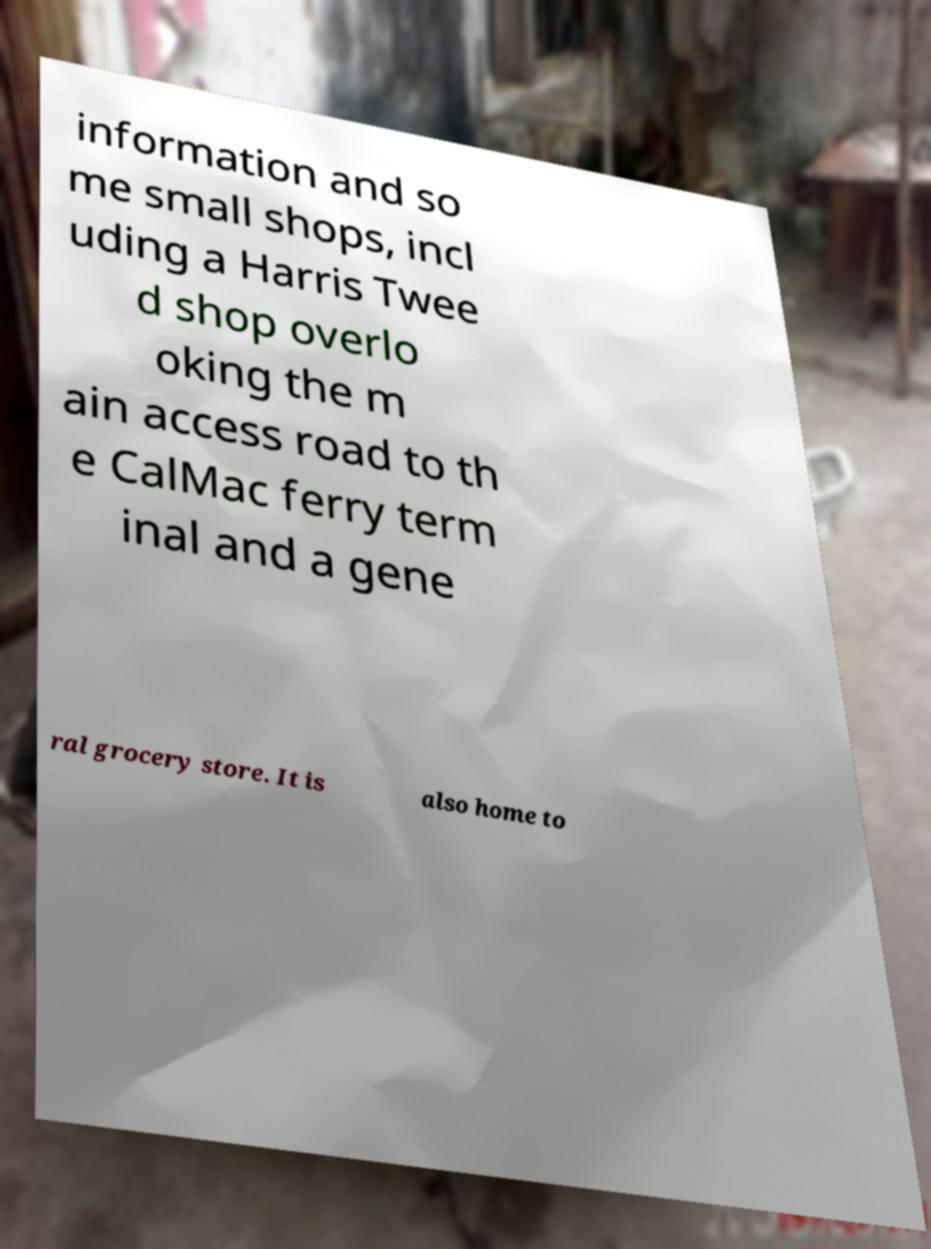Could you extract and type out the text from this image? information and so me small shops, incl uding a Harris Twee d shop overlo oking the m ain access road to th e CalMac ferry term inal and a gene ral grocery store. It is also home to 